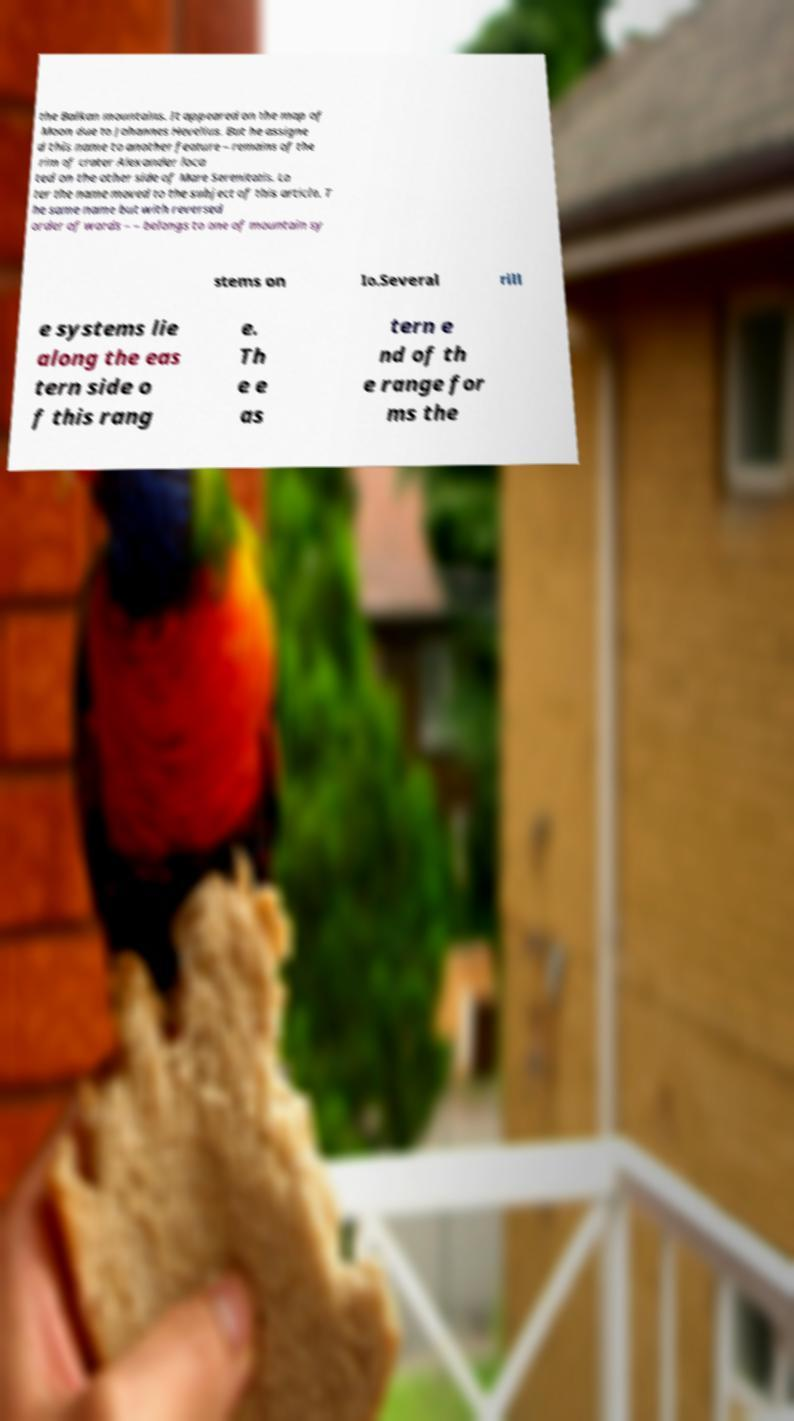Please identify and transcribe the text found in this image. the Balkan mountains. It appeared on the map of Moon due to Johannes Hevelius. But he assigne d this name to another feature – remains of the rim of crater Alexander loca ted on the other side of Mare Serenitatis. La ter the name moved to the subject of this article. T he same name but with reversed order of words – – belongs to one of mountain sy stems on Io.Several rill e systems lie along the eas tern side o f this rang e. Th e e as tern e nd of th e range for ms the 